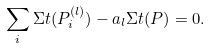Convert formula to latex. <formula><loc_0><loc_0><loc_500><loc_500>\sum _ { i } \Sigma t ( P _ { i } ^ { ( l ) } ) - a _ { l } \Sigma t ( P ) = 0 .</formula> 